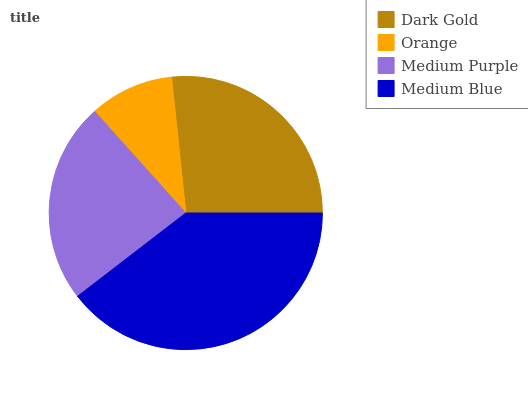Is Orange the minimum?
Answer yes or no. Yes. Is Medium Blue the maximum?
Answer yes or no. Yes. Is Medium Purple the minimum?
Answer yes or no. No. Is Medium Purple the maximum?
Answer yes or no. No. Is Medium Purple greater than Orange?
Answer yes or no. Yes. Is Orange less than Medium Purple?
Answer yes or no. Yes. Is Orange greater than Medium Purple?
Answer yes or no. No. Is Medium Purple less than Orange?
Answer yes or no. No. Is Dark Gold the high median?
Answer yes or no. Yes. Is Medium Purple the low median?
Answer yes or no. Yes. Is Medium Blue the high median?
Answer yes or no. No. Is Dark Gold the low median?
Answer yes or no. No. 